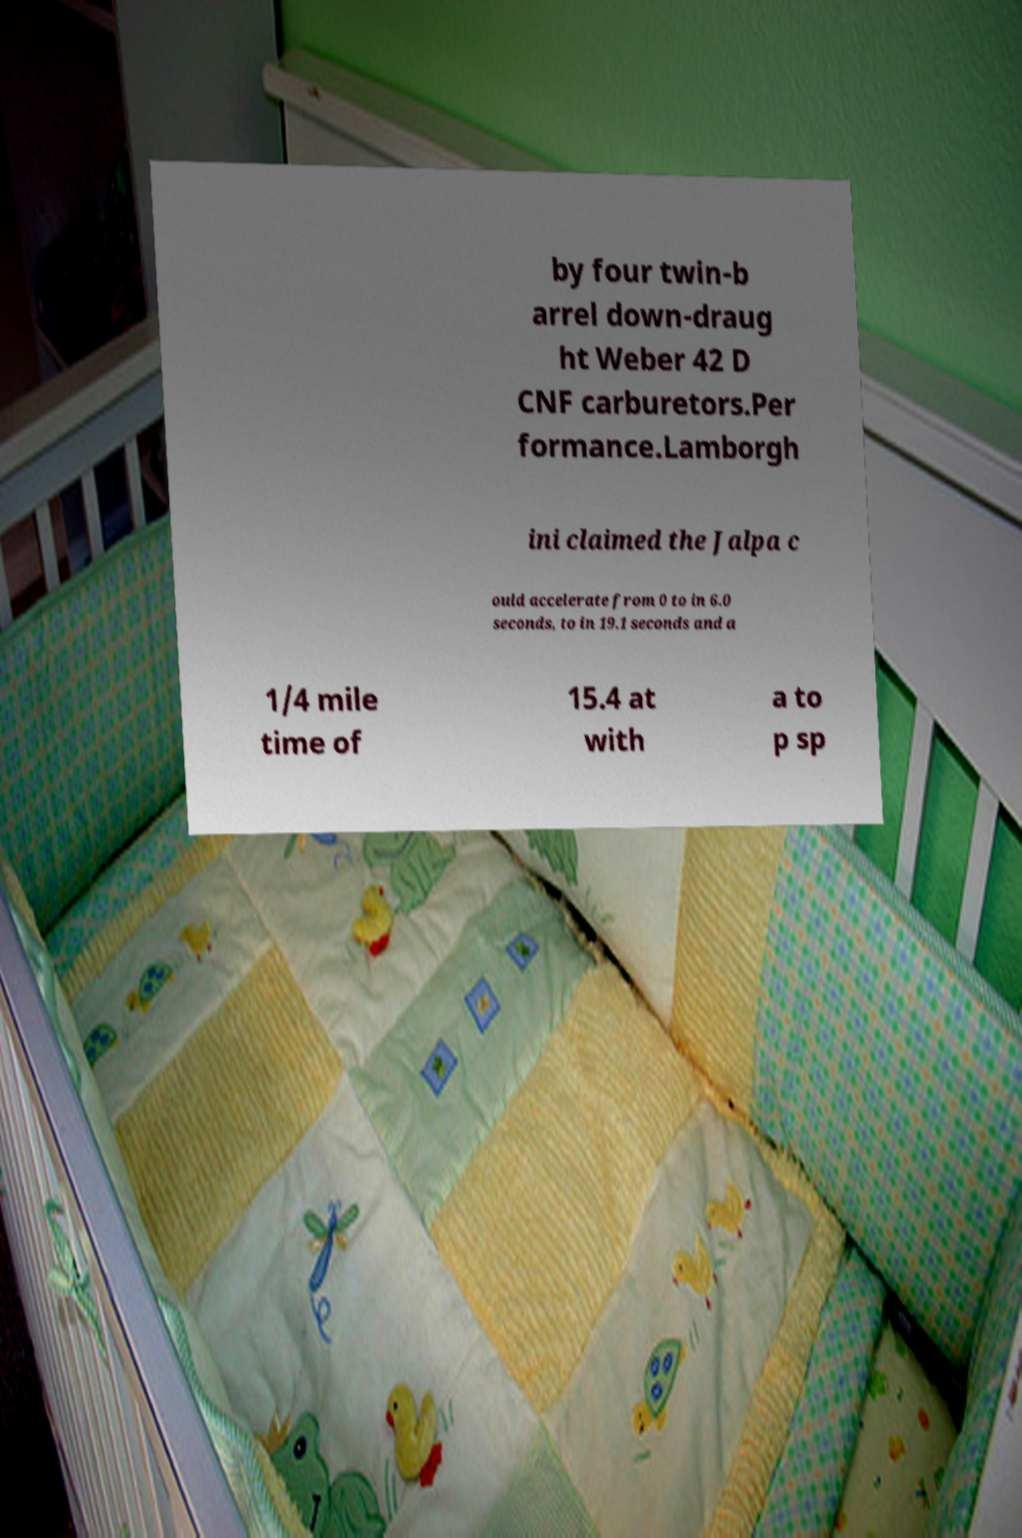Please read and relay the text visible in this image. What does it say? by four twin-b arrel down-draug ht Weber 42 D CNF carburetors.Per formance.Lamborgh ini claimed the Jalpa c ould accelerate from 0 to in 6.0 seconds, to in 19.1 seconds and a 1/4 mile time of 15.4 at with a to p sp 